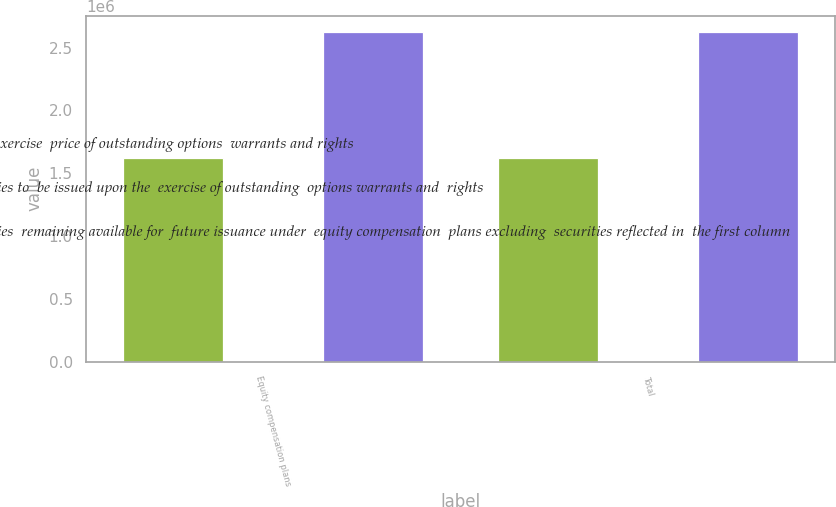Convert chart. <chart><loc_0><loc_0><loc_500><loc_500><stacked_bar_chart><ecel><fcel>Equity compensation plans<fcel>Total<nl><fcel>Weightedaverage exercise  price of outstanding options  warrants and rights<fcel>1.6231e+06<fcel>1.6231e+06<nl><fcel>Number of securities to  be issued upon the  exercise of outstanding  options warrants and  rights<fcel>22.17<fcel>22.17<nl><fcel>Number of securities  remaining available for  future issuance under  equity compensation  plans excluding  securities reflected in  the first column<fcel>2.62202e+06<fcel>2.62202e+06<nl></chart> 